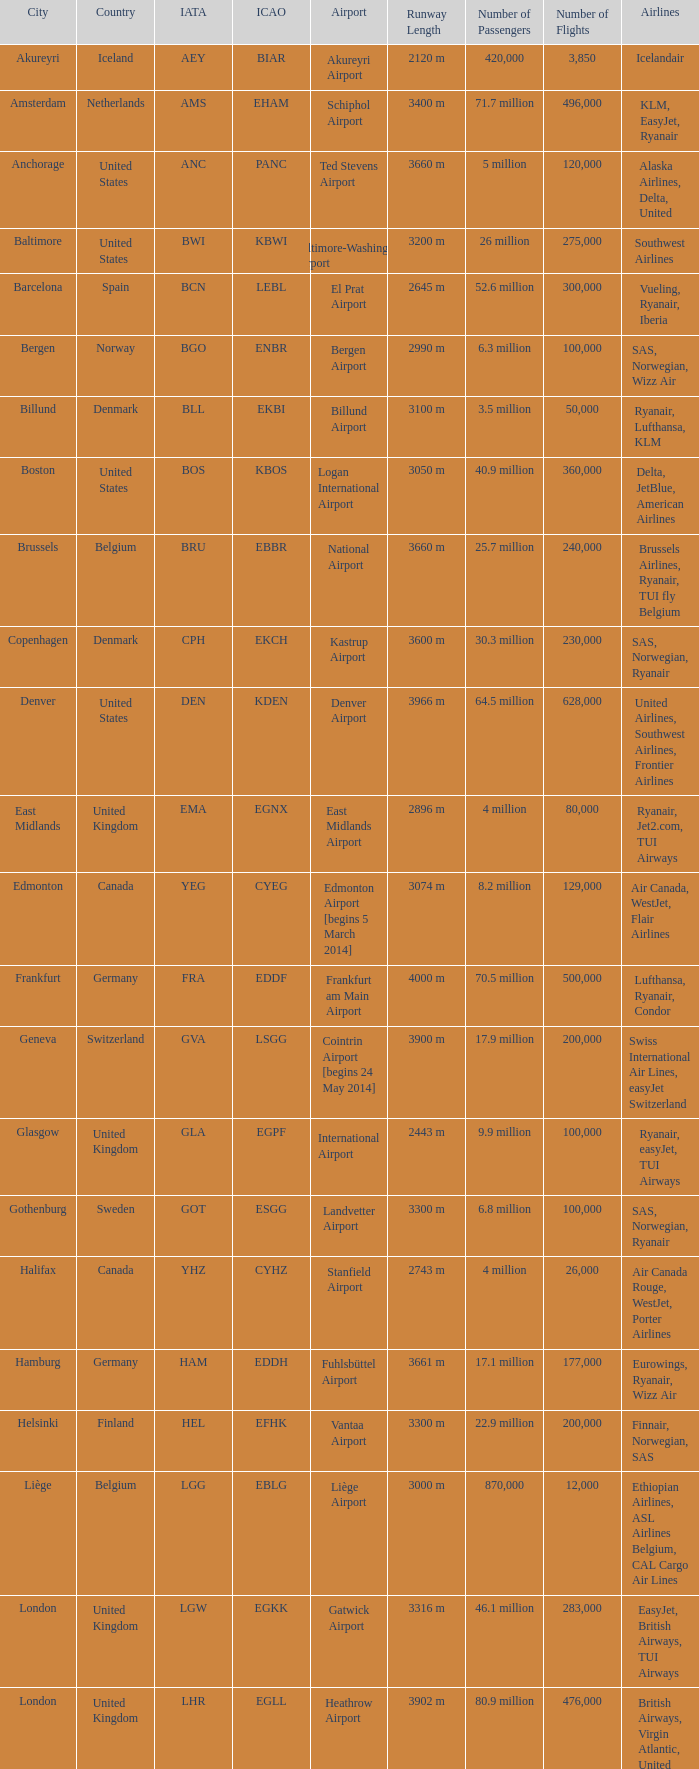What Airport's IATA is SEA? Seattle–Tacoma Airport. 